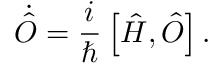Convert formula to latex. <formula><loc_0><loc_0><loc_500><loc_500>\dot { \hat { O } } = \frac { i } { } \left [ \hat { H } , \hat { O } \right ] .</formula> 